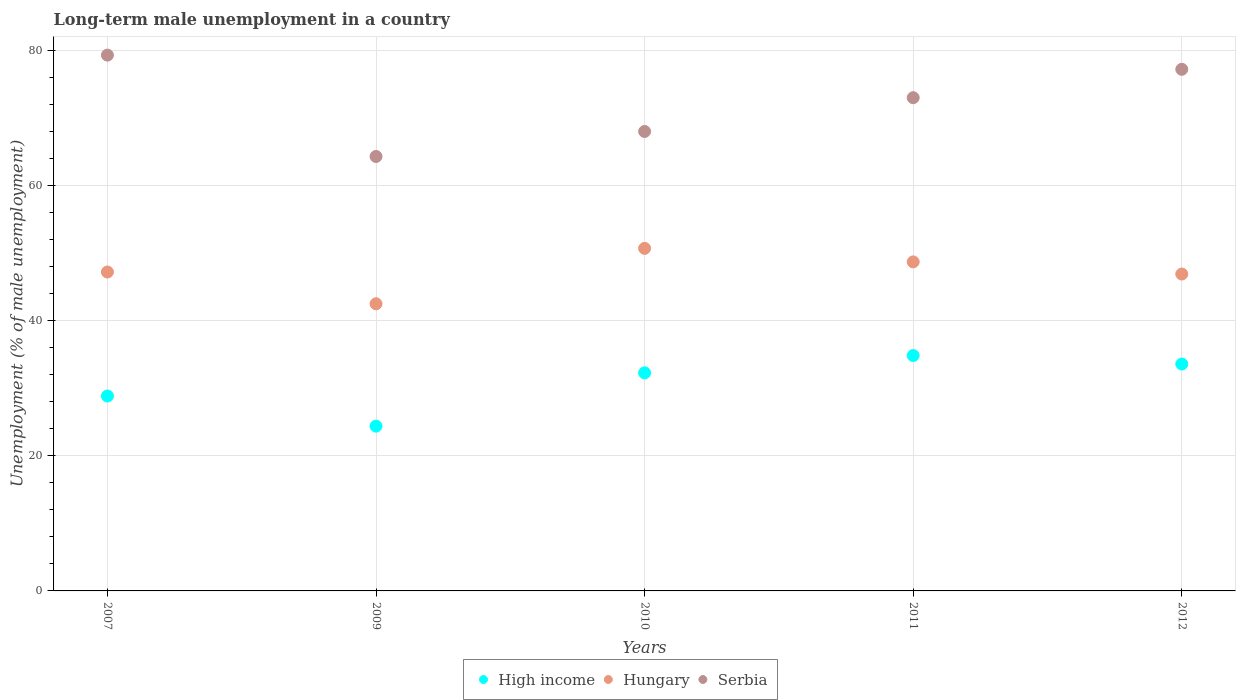How many different coloured dotlines are there?
Give a very brief answer. 3. Is the number of dotlines equal to the number of legend labels?
Your answer should be very brief. Yes. What is the percentage of long-term unemployed male population in High income in 2007?
Offer a very short reply. 28.85. Across all years, what is the maximum percentage of long-term unemployed male population in Serbia?
Keep it short and to the point. 79.3. Across all years, what is the minimum percentage of long-term unemployed male population in High income?
Give a very brief answer. 24.39. What is the total percentage of long-term unemployed male population in High income in the graph?
Provide a short and direct response. 153.93. What is the difference between the percentage of long-term unemployed male population in High income in 2009 and that in 2012?
Offer a terse response. -9.19. What is the difference between the percentage of long-term unemployed male population in High income in 2007 and the percentage of long-term unemployed male population in Hungary in 2012?
Provide a short and direct response. -18.05. What is the average percentage of long-term unemployed male population in Serbia per year?
Offer a terse response. 72.36. In the year 2012, what is the difference between the percentage of long-term unemployed male population in High income and percentage of long-term unemployed male population in Serbia?
Ensure brevity in your answer.  -43.62. In how many years, is the percentage of long-term unemployed male population in High income greater than 24 %?
Provide a succinct answer. 5. What is the ratio of the percentage of long-term unemployed male population in Serbia in 2009 to that in 2012?
Offer a very short reply. 0.83. Is the percentage of long-term unemployed male population in High income in 2009 less than that in 2010?
Keep it short and to the point. Yes. What is the difference between the highest and the second highest percentage of long-term unemployed male population in High income?
Give a very brief answer. 1.26. Is the sum of the percentage of long-term unemployed male population in Hungary in 2009 and 2010 greater than the maximum percentage of long-term unemployed male population in High income across all years?
Your answer should be very brief. Yes. Does the percentage of long-term unemployed male population in Serbia monotonically increase over the years?
Provide a short and direct response. No. Is the percentage of long-term unemployed male population in Serbia strictly greater than the percentage of long-term unemployed male population in High income over the years?
Keep it short and to the point. Yes. How many dotlines are there?
Provide a short and direct response. 3. How many years are there in the graph?
Your answer should be compact. 5. What is the difference between two consecutive major ticks on the Y-axis?
Your response must be concise. 20. How many legend labels are there?
Provide a succinct answer. 3. How are the legend labels stacked?
Provide a succinct answer. Horizontal. What is the title of the graph?
Provide a succinct answer. Long-term male unemployment in a country. What is the label or title of the X-axis?
Your answer should be compact. Years. What is the label or title of the Y-axis?
Keep it short and to the point. Unemployment (% of male unemployment). What is the Unemployment (% of male unemployment) of High income in 2007?
Make the answer very short. 28.85. What is the Unemployment (% of male unemployment) of Hungary in 2007?
Your answer should be very brief. 47.2. What is the Unemployment (% of male unemployment) in Serbia in 2007?
Your answer should be compact. 79.3. What is the Unemployment (% of male unemployment) of High income in 2009?
Offer a terse response. 24.39. What is the Unemployment (% of male unemployment) of Hungary in 2009?
Keep it short and to the point. 42.5. What is the Unemployment (% of male unemployment) of Serbia in 2009?
Your answer should be very brief. 64.3. What is the Unemployment (% of male unemployment) of High income in 2010?
Give a very brief answer. 32.28. What is the Unemployment (% of male unemployment) of Hungary in 2010?
Make the answer very short. 50.7. What is the Unemployment (% of male unemployment) in Serbia in 2010?
Your response must be concise. 68. What is the Unemployment (% of male unemployment) of High income in 2011?
Offer a terse response. 34.84. What is the Unemployment (% of male unemployment) in Hungary in 2011?
Ensure brevity in your answer.  48.7. What is the Unemployment (% of male unemployment) in High income in 2012?
Provide a succinct answer. 33.58. What is the Unemployment (% of male unemployment) of Hungary in 2012?
Your answer should be compact. 46.9. What is the Unemployment (% of male unemployment) in Serbia in 2012?
Make the answer very short. 77.2. Across all years, what is the maximum Unemployment (% of male unemployment) of High income?
Make the answer very short. 34.84. Across all years, what is the maximum Unemployment (% of male unemployment) in Hungary?
Offer a terse response. 50.7. Across all years, what is the maximum Unemployment (% of male unemployment) of Serbia?
Keep it short and to the point. 79.3. Across all years, what is the minimum Unemployment (% of male unemployment) in High income?
Ensure brevity in your answer.  24.39. Across all years, what is the minimum Unemployment (% of male unemployment) in Hungary?
Provide a succinct answer. 42.5. Across all years, what is the minimum Unemployment (% of male unemployment) in Serbia?
Make the answer very short. 64.3. What is the total Unemployment (% of male unemployment) in High income in the graph?
Offer a terse response. 153.93. What is the total Unemployment (% of male unemployment) of Hungary in the graph?
Offer a terse response. 236. What is the total Unemployment (% of male unemployment) of Serbia in the graph?
Provide a short and direct response. 361.8. What is the difference between the Unemployment (% of male unemployment) of High income in 2007 and that in 2009?
Your answer should be very brief. 4.46. What is the difference between the Unemployment (% of male unemployment) in Hungary in 2007 and that in 2009?
Your answer should be compact. 4.7. What is the difference between the Unemployment (% of male unemployment) of Serbia in 2007 and that in 2009?
Your answer should be very brief. 15. What is the difference between the Unemployment (% of male unemployment) of High income in 2007 and that in 2010?
Offer a terse response. -3.43. What is the difference between the Unemployment (% of male unemployment) in High income in 2007 and that in 2011?
Offer a very short reply. -5.99. What is the difference between the Unemployment (% of male unemployment) in Hungary in 2007 and that in 2011?
Make the answer very short. -1.5. What is the difference between the Unemployment (% of male unemployment) of Serbia in 2007 and that in 2011?
Offer a terse response. 6.3. What is the difference between the Unemployment (% of male unemployment) of High income in 2007 and that in 2012?
Your answer should be very brief. -4.73. What is the difference between the Unemployment (% of male unemployment) of Serbia in 2007 and that in 2012?
Make the answer very short. 2.1. What is the difference between the Unemployment (% of male unemployment) of High income in 2009 and that in 2010?
Your response must be concise. -7.89. What is the difference between the Unemployment (% of male unemployment) in Serbia in 2009 and that in 2010?
Offer a very short reply. -3.7. What is the difference between the Unemployment (% of male unemployment) of High income in 2009 and that in 2011?
Offer a very short reply. -10.45. What is the difference between the Unemployment (% of male unemployment) in Hungary in 2009 and that in 2011?
Keep it short and to the point. -6.2. What is the difference between the Unemployment (% of male unemployment) of Serbia in 2009 and that in 2011?
Make the answer very short. -8.7. What is the difference between the Unemployment (% of male unemployment) of High income in 2009 and that in 2012?
Keep it short and to the point. -9.19. What is the difference between the Unemployment (% of male unemployment) in Serbia in 2009 and that in 2012?
Keep it short and to the point. -12.9. What is the difference between the Unemployment (% of male unemployment) in High income in 2010 and that in 2011?
Your answer should be very brief. -2.56. What is the difference between the Unemployment (% of male unemployment) of Hungary in 2010 and that in 2011?
Give a very brief answer. 2. What is the difference between the Unemployment (% of male unemployment) in Serbia in 2010 and that in 2011?
Your answer should be compact. -5. What is the difference between the Unemployment (% of male unemployment) of High income in 2010 and that in 2012?
Your response must be concise. -1.3. What is the difference between the Unemployment (% of male unemployment) of Hungary in 2010 and that in 2012?
Offer a terse response. 3.8. What is the difference between the Unemployment (% of male unemployment) of High income in 2011 and that in 2012?
Offer a terse response. 1.26. What is the difference between the Unemployment (% of male unemployment) in High income in 2007 and the Unemployment (% of male unemployment) in Hungary in 2009?
Your answer should be compact. -13.65. What is the difference between the Unemployment (% of male unemployment) in High income in 2007 and the Unemployment (% of male unemployment) in Serbia in 2009?
Provide a short and direct response. -35.45. What is the difference between the Unemployment (% of male unemployment) in Hungary in 2007 and the Unemployment (% of male unemployment) in Serbia in 2009?
Make the answer very short. -17.1. What is the difference between the Unemployment (% of male unemployment) in High income in 2007 and the Unemployment (% of male unemployment) in Hungary in 2010?
Ensure brevity in your answer.  -21.85. What is the difference between the Unemployment (% of male unemployment) in High income in 2007 and the Unemployment (% of male unemployment) in Serbia in 2010?
Make the answer very short. -39.15. What is the difference between the Unemployment (% of male unemployment) of Hungary in 2007 and the Unemployment (% of male unemployment) of Serbia in 2010?
Your response must be concise. -20.8. What is the difference between the Unemployment (% of male unemployment) of High income in 2007 and the Unemployment (% of male unemployment) of Hungary in 2011?
Keep it short and to the point. -19.85. What is the difference between the Unemployment (% of male unemployment) in High income in 2007 and the Unemployment (% of male unemployment) in Serbia in 2011?
Your response must be concise. -44.15. What is the difference between the Unemployment (% of male unemployment) of Hungary in 2007 and the Unemployment (% of male unemployment) of Serbia in 2011?
Keep it short and to the point. -25.8. What is the difference between the Unemployment (% of male unemployment) in High income in 2007 and the Unemployment (% of male unemployment) in Hungary in 2012?
Your response must be concise. -18.05. What is the difference between the Unemployment (% of male unemployment) in High income in 2007 and the Unemployment (% of male unemployment) in Serbia in 2012?
Make the answer very short. -48.35. What is the difference between the Unemployment (% of male unemployment) in High income in 2009 and the Unemployment (% of male unemployment) in Hungary in 2010?
Your response must be concise. -26.31. What is the difference between the Unemployment (% of male unemployment) of High income in 2009 and the Unemployment (% of male unemployment) of Serbia in 2010?
Ensure brevity in your answer.  -43.61. What is the difference between the Unemployment (% of male unemployment) in Hungary in 2009 and the Unemployment (% of male unemployment) in Serbia in 2010?
Keep it short and to the point. -25.5. What is the difference between the Unemployment (% of male unemployment) of High income in 2009 and the Unemployment (% of male unemployment) of Hungary in 2011?
Your answer should be very brief. -24.31. What is the difference between the Unemployment (% of male unemployment) in High income in 2009 and the Unemployment (% of male unemployment) in Serbia in 2011?
Offer a very short reply. -48.61. What is the difference between the Unemployment (% of male unemployment) of Hungary in 2009 and the Unemployment (% of male unemployment) of Serbia in 2011?
Your answer should be very brief. -30.5. What is the difference between the Unemployment (% of male unemployment) of High income in 2009 and the Unemployment (% of male unemployment) of Hungary in 2012?
Offer a very short reply. -22.51. What is the difference between the Unemployment (% of male unemployment) in High income in 2009 and the Unemployment (% of male unemployment) in Serbia in 2012?
Keep it short and to the point. -52.81. What is the difference between the Unemployment (% of male unemployment) in Hungary in 2009 and the Unemployment (% of male unemployment) in Serbia in 2012?
Your answer should be very brief. -34.7. What is the difference between the Unemployment (% of male unemployment) in High income in 2010 and the Unemployment (% of male unemployment) in Hungary in 2011?
Offer a very short reply. -16.42. What is the difference between the Unemployment (% of male unemployment) in High income in 2010 and the Unemployment (% of male unemployment) in Serbia in 2011?
Your answer should be very brief. -40.72. What is the difference between the Unemployment (% of male unemployment) in Hungary in 2010 and the Unemployment (% of male unemployment) in Serbia in 2011?
Provide a short and direct response. -22.3. What is the difference between the Unemployment (% of male unemployment) of High income in 2010 and the Unemployment (% of male unemployment) of Hungary in 2012?
Keep it short and to the point. -14.62. What is the difference between the Unemployment (% of male unemployment) of High income in 2010 and the Unemployment (% of male unemployment) of Serbia in 2012?
Give a very brief answer. -44.92. What is the difference between the Unemployment (% of male unemployment) of Hungary in 2010 and the Unemployment (% of male unemployment) of Serbia in 2012?
Offer a very short reply. -26.5. What is the difference between the Unemployment (% of male unemployment) in High income in 2011 and the Unemployment (% of male unemployment) in Hungary in 2012?
Offer a very short reply. -12.06. What is the difference between the Unemployment (% of male unemployment) in High income in 2011 and the Unemployment (% of male unemployment) in Serbia in 2012?
Give a very brief answer. -42.36. What is the difference between the Unemployment (% of male unemployment) in Hungary in 2011 and the Unemployment (% of male unemployment) in Serbia in 2012?
Your answer should be very brief. -28.5. What is the average Unemployment (% of male unemployment) of High income per year?
Offer a very short reply. 30.79. What is the average Unemployment (% of male unemployment) in Hungary per year?
Your answer should be very brief. 47.2. What is the average Unemployment (% of male unemployment) of Serbia per year?
Provide a short and direct response. 72.36. In the year 2007, what is the difference between the Unemployment (% of male unemployment) of High income and Unemployment (% of male unemployment) of Hungary?
Your answer should be very brief. -18.35. In the year 2007, what is the difference between the Unemployment (% of male unemployment) in High income and Unemployment (% of male unemployment) in Serbia?
Provide a short and direct response. -50.45. In the year 2007, what is the difference between the Unemployment (% of male unemployment) of Hungary and Unemployment (% of male unemployment) of Serbia?
Your answer should be compact. -32.1. In the year 2009, what is the difference between the Unemployment (% of male unemployment) in High income and Unemployment (% of male unemployment) in Hungary?
Ensure brevity in your answer.  -18.11. In the year 2009, what is the difference between the Unemployment (% of male unemployment) of High income and Unemployment (% of male unemployment) of Serbia?
Offer a terse response. -39.91. In the year 2009, what is the difference between the Unemployment (% of male unemployment) in Hungary and Unemployment (% of male unemployment) in Serbia?
Provide a short and direct response. -21.8. In the year 2010, what is the difference between the Unemployment (% of male unemployment) in High income and Unemployment (% of male unemployment) in Hungary?
Provide a short and direct response. -18.42. In the year 2010, what is the difference between the Unemployment (% of male unemployment) of High income and Unemployment (% of male unemployment) of Serbia?
Give a very brief answer. -35.72. In the year 2010, what is the difference between the Unemployment (% of male unemployment) of Hungary and Unemployment (% of male unemployment) of Serbia?
Provide a short and direct response. -17.3. In the year 2011, what is the difference between the Unemployment (% of male unemployment) of High income and Unemployment (% of male unemployment) of Hungary?
Provide a succinct answer. -13.86. In the year 2011, what is the difference between the Unemployment (% of male unemployment) of High income and Unemployment (% of male unemployment) of Serbia?
Your response must be concise. -38.16. In the year 2011, what is the difference between the Unemployment (% of male unemployment) in Hungary and Unemployment (% of male unemployment) in Serbia?
Make the answer very short. -24.3. In the year 2012, what is the difference between the Unemployment (% of male unemployment) in High income and Unemployment (% of male unemployment) in Hungary?
Provide a short and direct response. -13.32. In the year 2012, what is the difference between the Unemployment (% of male unemployment) in High income and Unemployment (% of male unemployment) in Serbia?
Keep it short and to the point. -43.62. In the year 2012, what is the difference between the Unemployment (% of male unemployment) in Hungary and Unemployment (% of male unemployment) in Serbia?
Your answer should be compact. -30.3. What is the ratio of the Unemployment (% of male unemployment) in High income in 2007 to that in 2009?
Provide a succinct answer. 1.18. What is the ratio of the Unemployment (% of male unemployment) of Hungary in 2007 to that in 2009?
Give a very brief answer. 1.11. What is the ratio of the Unemployment (% of male unemployment) in Serbia in 2007 to that in 2009?
Keep it short and to the point. 1.23. What is the ratio of the Unemployment (% of male unemployment) of High income in 2007 to that in 2010?
Your answer should be compact. 0.89. What is the ratio of the Unemployment (% of male unemployment) of Serbia in 2007 to that in 2010?
Offer a terse response. 1.17. What is the ratio of the Unemployment (% of male unemployment) in High income in 2007 to that in 2011?
Make the answer very short. 0.83. What is the ratio of the Unemployment (% of male unemployment) in Hungary in 2007 to that in 2011?
Keep it short and to the point. 0.97. What is the ratio of the Unemployment (% of male unemployment) in Serbia in 2007 to that in 2011?
Give a very brief answer. 1.09. What is the ratio of the Unemployment (% of male unemployment) of High income in 2007 to that in 2012?
Make the answer very short. 0.86. What is the ratio of the Unemployment (% of male unemployment) in Hungary in 2007 to that in 2012?
Provide a short and direct response. 1.01. What is the ratio of the Unemployment (% of male unemployment) of Serbia in 2007 to that in 2012?
Give a very brief answer. 1.03. What is the ratio of the Unemployment (% of male unemployment) in High income in 2009 to that in 2010?
Make the answer very short. 0.76. What is the ratio of the Unemployment (% of male unemployment) in Hungary in 2009 to that in 2010?
Your answer should be compact. 0.84. What is the ratio of the Unemployment (% of male unemployment) of Serbia in 2009 to that in 2010?
Your response must be concise. 0.95. What is the ratio of the Unemployment (% of male unemployment) in Hungary in 2009 to that in 2011?
Ensure brevity in your answer.  0.87. What is the ratio of the Unemployment (% of male unemployment) of Serbia in 2009 to that in 2011?
Keep it short and to the point. 0.88. What is the ratio of the Unemployment (% of male unemployment) in High income in 2009 to that in 2012?
Give a very brief answer. 0.73. What is the ratio of the Unemployment (% of male unemployment) of Hungary in 2009 to that in 2012?
Offer a terse response. 0.91. What is the ratio of the Unemployment (% of male unemployment) in Serbia in 2009 to that in 2012?
Make the answer very short. 0.83. What is the ratio of the Unemployment (% of male unemployment) of High income in 2010 to that in 2011?
Offer a very short reply. 0.93. What is the ratio of the Unemployment (% of male unemployment) of Hungary in 2010 to that in 2011?
Provide a succinct answer. 1.04. What is the ratio of the Unemployment (% of male unemployment) of Serbia in 2010 to that in 2011?
Provide a short and direct response. 0.93. What is the ratio of the Unemployment (% of male unemployment) in High income in 2010 to that in 2012?
Provide a succinct answer. 0.96. What is the ratio of the Unemployment (% of male unemployment) of Hungary in 2010 to that in 2012?
Give a very brief answer. 1.08. What is the ratio of the Unemployment (% of male unemployment) in Serbia in 2010 to that in 2012?
Make the answer very short. 0.88. What is the ratio of the Unemployment (% of male unemployment) of High income in 2011 to that in 2012?
Keep it short and to the point. 1.04. What is the ratio of the Unemployment (% of male unemployment) in Hungary in 2011 to that in 2012?
Your answer should be very brief. 1.04. What is the ratio of the Unemployment (% of male unemployment) of Serbia in 2011 to that in 2012?
Offer a very short reply. 0.95. What is the difference between the highest and the second highest Unemployment (% of male unemployment) of High income?
Keep it short and to the point. 1.26. What is the difference between the highest and the lowest Unemployment (% of male unemployment) in High income?
Provide a succinct answer. 10.45. What is the difference between the highest and the lowest Unemployment (% of male unemployment) of Serbia?
Give a very brief answer. 15. 